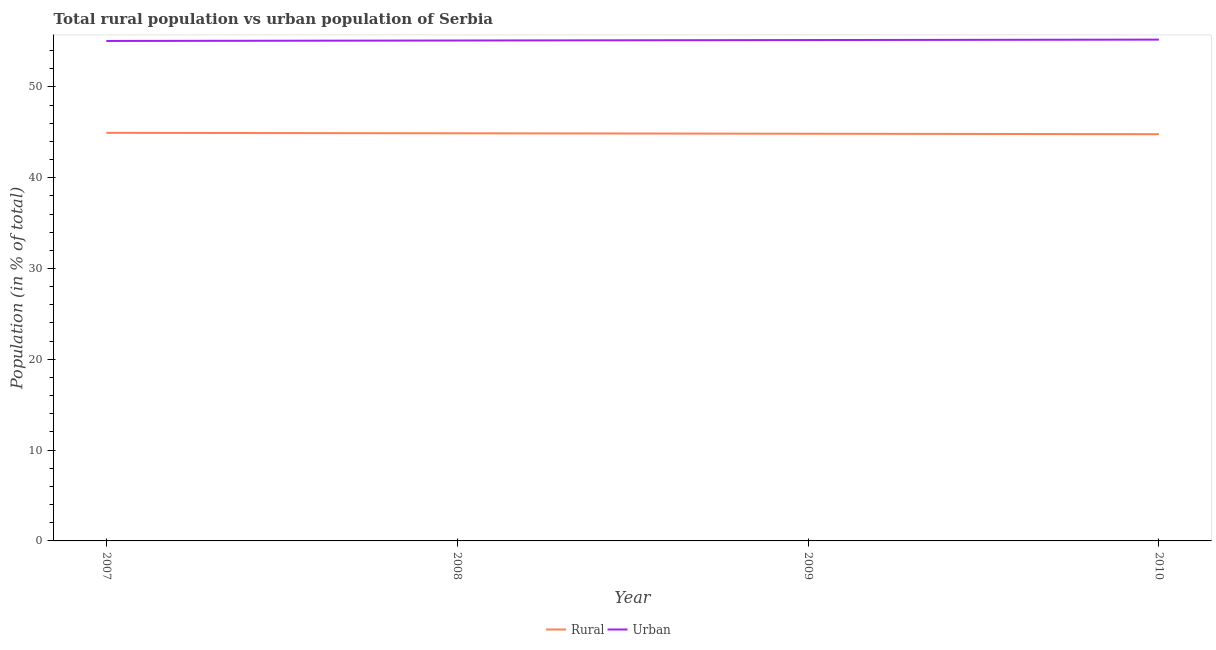How many different coloured lines are there?
Your response must be concise. 2. Does the line corresponding to urban population intersect with the line corresponding to rural population?
Provide a short and direct response. No. What is the rural population in 2007?
Make the answer very short. 44.94. Across all years, what is the maximum rural population?
Give a very brief answer. 44.94. Across all years, what is the minimum urban population?
Your answer should be compact. 55.06. In which year was the urban population minimum?
Your answer should be very brief. 2007. What is the total rural population in the graph?
Your answer should be very brief. 179.46. What is the difference between the urban population in 2009 and that in 2010?
Your response must be concise. -0.05. What is the difference between the rural population in 2008 and the urban population in 2009?
Offer a very short reply. -10.27. What is the average urban population per year?
Your answer should be compact. 55.13. In the year 2010, what is the difference between the urban population and rural population?
Keep it short and to the point. 10.42. What is the ratio of the rural population in 2009 to that in 2010?
Offer a very short reply. 1. What is the difference between the highest and the second highest urban population?
Your answer should be very brief. 0.05. What is the difference between the highest and the lowest rural population?
Your answer should be very brief. 0.15. Is the sum of the rural population in 2008 and 2010 greater than the maximum urban population across all years?
Provide a short and direct response. Yes. Is the urban population strictly less than the rural population over the years?
Give a very brief answer. No. Does the graph contain any zero values?
Offer a very short reply. No. How are the legend labels stacked?
Offer a very short reply. Horizontal. What is the title of the graph?
Your response must be concise. Total rural population vs urban population of Serbia. What is the label or title of the Y-axis?
Your answer should be very brief. Population (in % of total). What is the Population (in % of total) of Rural in 2007?
Offer a terse response. 44.94. What is the Population (in % of total) in Urban in 2007?
Give a very brief answer. 55.06. What is the Population (in % of total) of Rural in 2008?
Your answer should be very brief. 44.89. What is the Population (in % of total) of Urban in 2008?
Keep it short and to the point. 55.11. What is the Population (in % of total) in Rural in 2009?
Provide a succinct answer. 44.84. What is the Population (in % of total) of Urban in 2009?
Your answer should be very brief. 55.16. What is the Population (in % of total) in Rural in 2010?
Your answer should be compact. 44.79. What is the Population (in % of total) in Urban in 2010?
Give a very brief answer. 55.21. Across all years, what is the maximum Population (in % of total) of Rural?
Provide a short and direct response. 44.94. Across all years, what is the maximum Population (in % of total) of Urban?
Provide a succinct answer. 55.21. Across all years, what is the minimum Population (in % of total) of Rural?
Your answer should be compact. 44.79. Across all years, what is the minimum Population (in % of total) of Urban?
Provide a short and direct response. 55.06. What is the total Population (in % of total) of Rural in the graph?
Your response must be concise. 179.46. What is the total Population (in % of total) of Urban in the graph?
Provide a succinct answer. 220.54. What is the difference between the Population (in % of total) of Rural in 2007 and that in 2008?
Your answer should be compact. 0.05. What is the difference between the Population (in % of total) in Rural in 2007 and that in 2009?
Your answer should be very brief. 0.1. What is the difference between the Population (in % of total) in Urban in 2007 and that in 2009?
Offer a terse response. -0.1. What is the difference between the Population (in % of total) in Rural in 2007 and that in 2010?
Give a very brief answer. 0.15. What is the difference between the Population (in % of total) of Urban in 2007 and that in 2010?
Offer a very short reply. -0.15. What is the difference between the Population (in % of total) in Rural in 2008 and that in 2009?
Make the answer very short. 0.05. What is the difference between the Population (in % of total) of Urban in 2008 and that in 2009?
Your response must be concise. -0.05. What is the difference between the Population (in % of total) of Rural in 2008 and that in 2010?
Offer a very short reply. 0.1. What is the difference between the Population (in % of total) of Urban in 2008 and that in 2010?
Offer a terse response. -0.1. What is the difference between the Population (in % of total) of Rural in 2009 and that in 2010?
Your response must be concise. 0.05. What is the difference between the Population (in % of total) in Urban in 2009 and that in 2010?
Your response must be concise. -0.05. What is the difference between the Population (in % of total) in Rural in 2007 and the Population (in % of total) in Urban in 2008?
Your response must be concise. -10.17. What is the difference between the Population (in % of total) of Rural in 2007 and the Population (in % of total) of Urban in 2009?
Offer a terse response. -10.22. What is the difference between the Population (in % of total) in Rural in 2007 and the Population (in % of total) in Urban in 2010?
Your answer should be very brief. -10.27. What is the difference between the Population (in % of total) of Rural in 2008 and the Population (in % of total) of Urban in 2009?
Your response must be concise. -10.27. What is the difference between the Population (in % of total) of Rural in 2008 and the Population (in % of total) of Urban in 2010?
Make the answer very short. -10.32. What is the difference between the Population (in % of total) of Rural in 2009 and the Population (in % of total) of Urban in 2010?
Your answer should be compact. -10.37. What is the average Population (in % of total) of Rural per year?
Provide a succinct answer. 44.87. What is the average Population (in % of total) in Urban per year?
Your response must be concise. 55.13. In the year 2007, what is the difference between the Population (in % of total) of Rural and Population (in % of total) of Urban?
Your response must be concise. -10.12. In the year 2008, what is the difference between the Population (in % of total) of Rural and Population (in % of total) of Urban?
Your answer should be compact. -10.22. In the year 2009, what is the difference between the Population (in % of total) of Rural and Population (in % of total) of Urban?
Offer a very short reply. -10.32. In the year 2010, what is the difference between the Population (in % of total) of Rural and Population (in % of total) of Urban?
Make the answer very short. -10.42. What is the ratio of the Population (in % of total) in Rural in 2007 to that in 2008?
Provide a succinct answer. 1. What is the ratio of the Population (in % of total) of Urban in 2007 to that in 2008?
Offer a terse response. 1. What is the ratio of the Population (in % of total) in Rural in 2009 to that in 2010?
Provide a short and direct response. 1. What is the difference between the highest and the second highest Population (in % of total) of Rural?
Provide a succinct answer. 0.05. What is the difference between the highest and the second highest Population (in % of total) in Urban?
Offer a very short reply. 0.05. What is the difference between the highest and the lowest Population (in % of total) in Rural?
Give a very brief answer. 0.15. What is the difference between the highest and the lowest Population (in % of total) of Urban?
Keep it short and to the point. 0.15. 